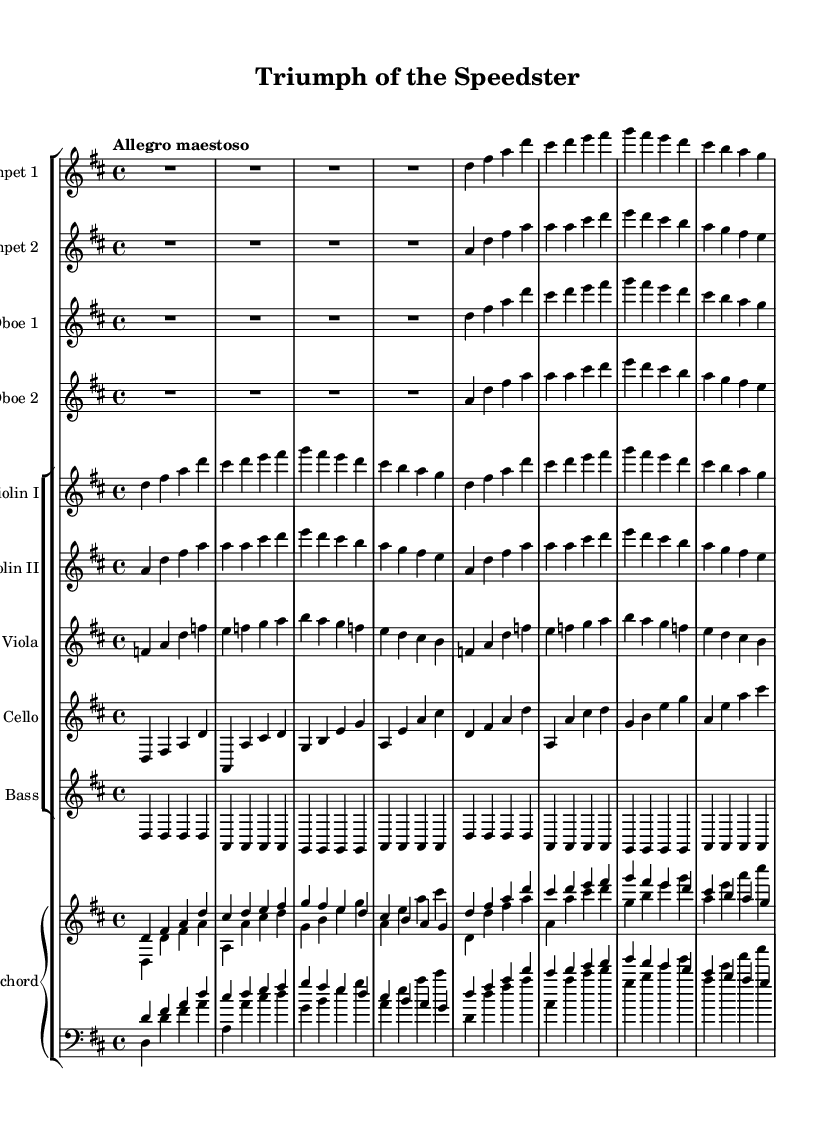What is the key signature of this music? The key signature indicates D major, which has two sharps (F# and C#). You can identify the key signature by looking at the sharp symbols at the beginning of the staff, specifically, the F and C lines, which indicate their positions.
Answer: D major What is the time signature of this music? The time signature is 4/4, as indicated at the beginning of the score after the key signature. This means there are four beats in each measure and the quarter note receives one beat.
Answer: 4/4 What tempo is specified for this piece? The tempo marking is "Allegro maestoso," suggesting a lively and majestic pace. "Allegro" typically indicates a fast tempo, while "maestoso" implies a grand or stately manner. You can find this tempo indication above the staff at the beginning of the piece.
Answer: Allegro maestoso How many instruments are featured in this overture? The overture features a total of 10 instruments: 2 trumpets, 2 oboes, 2 violins, 1 viola, 1 cello, 1 double bass, and 1 harpsichord. The instruments can be counted by looking at each individual staff in the score.
Answer: 10 Which instruments play in unison in this piece? The trumpet one and oboe one parts are written with the same pitches, playing in unison throughout the introduction of the piece. By comparing the notes in their respective staves, it can be seen that they align perfectly.
Answer: Trumpet 1 and Oboe 1 What is the dominant note in the initial motif? The dominant note in the initial motif is D. This note appears repeatedly in the first measures for both the trumpet and oboe parts, indicating it as the foundation or starting pitch of the motif.
Answer: D Which musical form is evident in this overture type? The overture demonstrates characteristics of sonata form, often used in Baroque music, featuring an exposition, development, and recapitulation. This can be inferred from the structure of thematic material presented in the different instrument sections.
Answer: Sonata form 